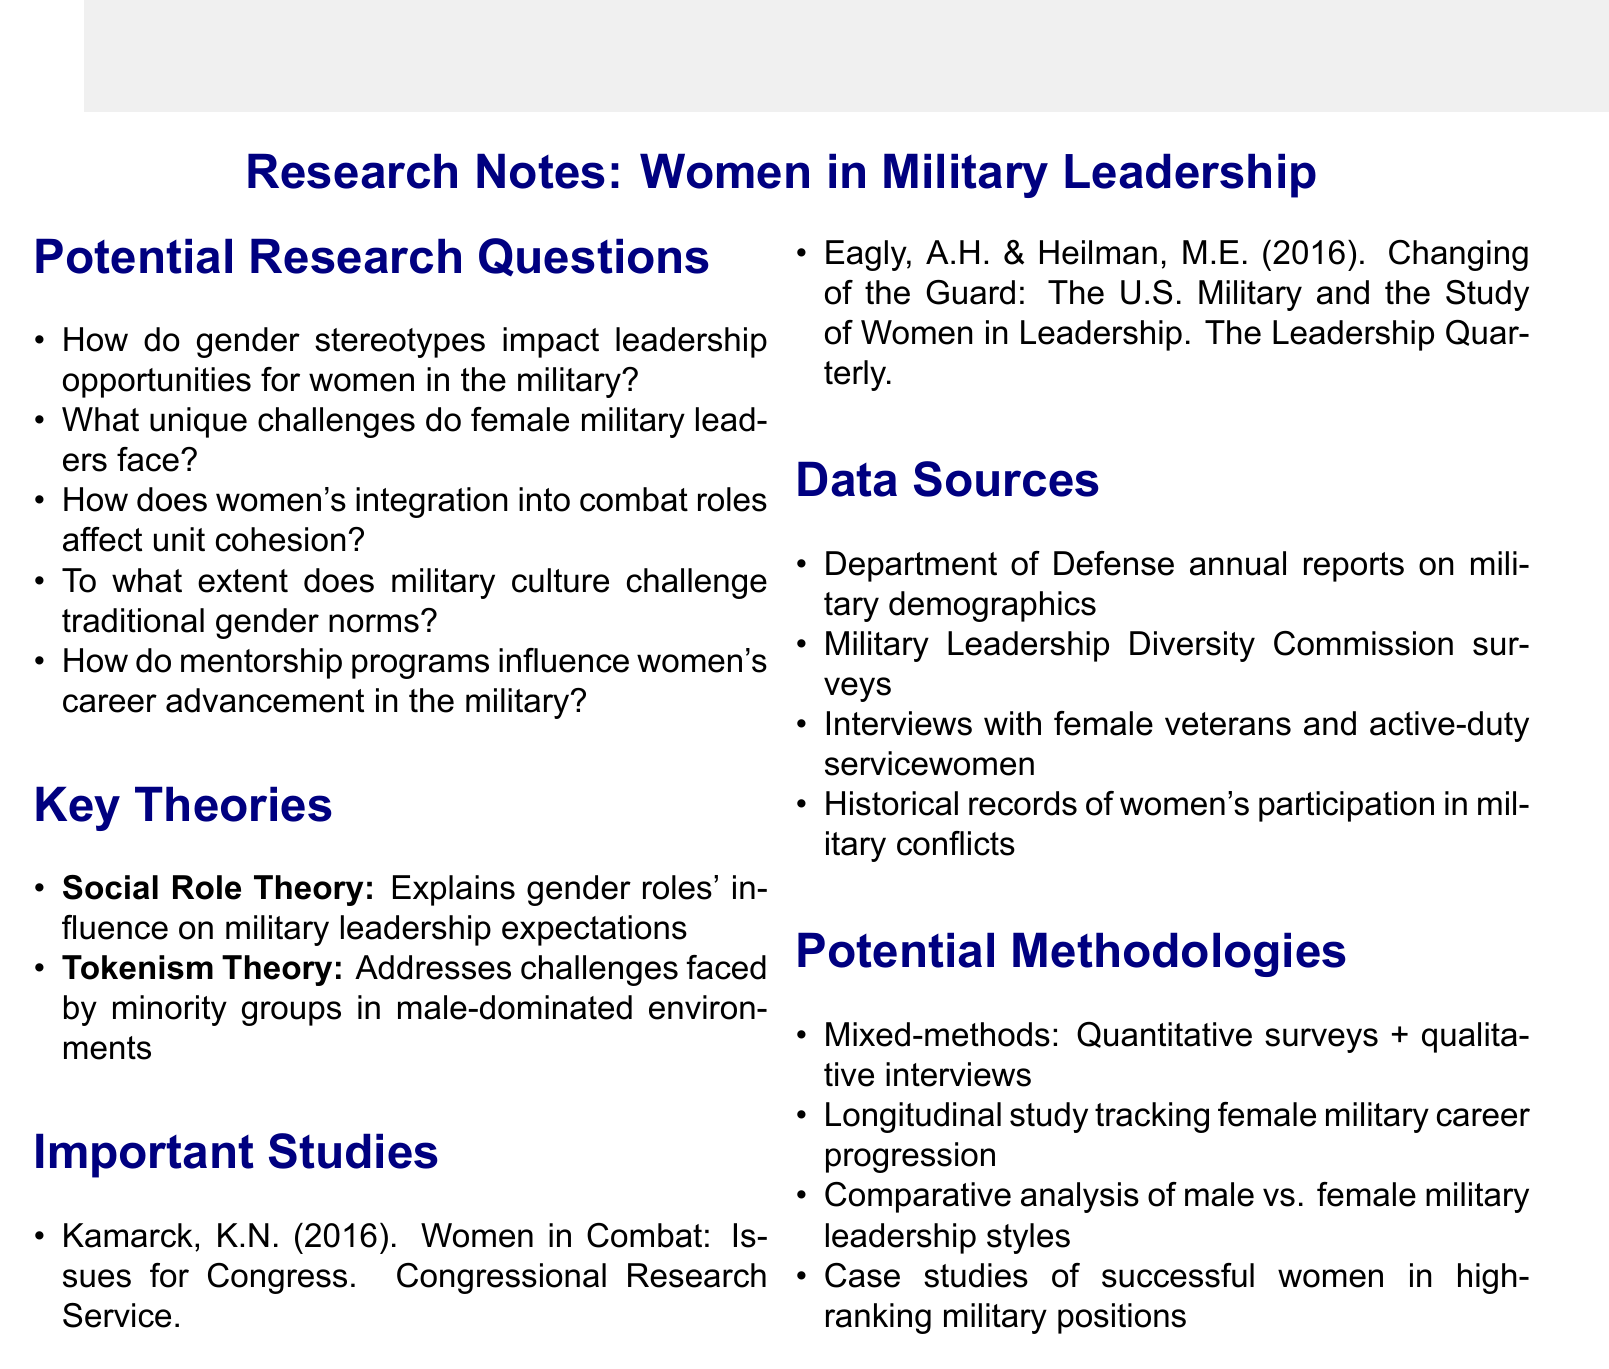What is the first potential research question listed? The first potential research question is directly stated in the document.
Answer: How do gender stereotypes impact leadership opportunities for women in the military? Who authored the study "Changing of the Guard"? The authors of this study are listed in the document under important studies.
Answer: Eagly, A.H. & Heilman, M.E What year was the study "Women in Combat: Issues for Congress" published? The publication year is explicitly mentioned in the important studies section of the document.
Answer: 2016 What key theory explains how gender roles influence leadership expectations? The document clearly specifies the name of the theory that addresses this issue.
Answer: Social Role Theory What type of approach does the potential methodologies suggest for research? The document describes one type of approach in the methodologies section.
Answer: Mixed-methods How many potential research questions are listed in the document? The number of research questions can be counted from the potential research questions section.
Answer: Five What data source involves interviews with female military personnel? The document mentions specific data sources for consideration, one of which involves interviews.
Answer: Interviews with female veterans and active-duty servicewomen What is one of the challenges addressed by Tokenism Theory? The document states the focus of Tokenism Theory in the key theories section.
Answer: Challenges faced by minority groups in male-dominated environments 